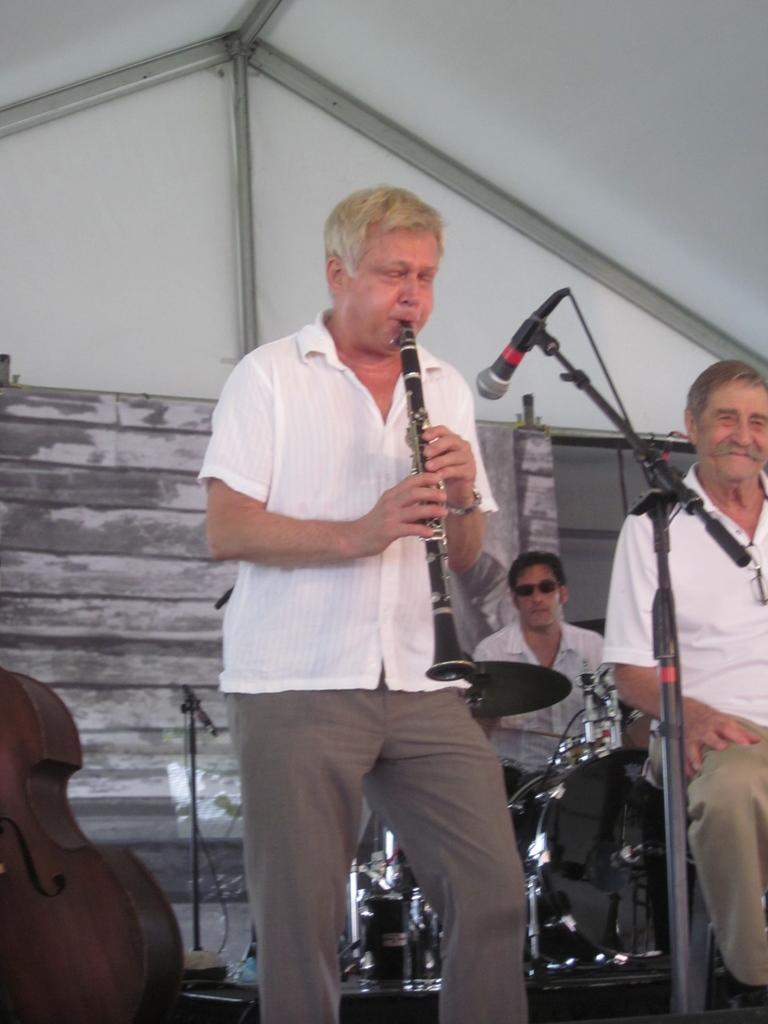Can you describe this image briefly? In this picture we can see people,here we can see a person is holding a clarinet,mic,drums,guitar and in the background we can see a wall. 